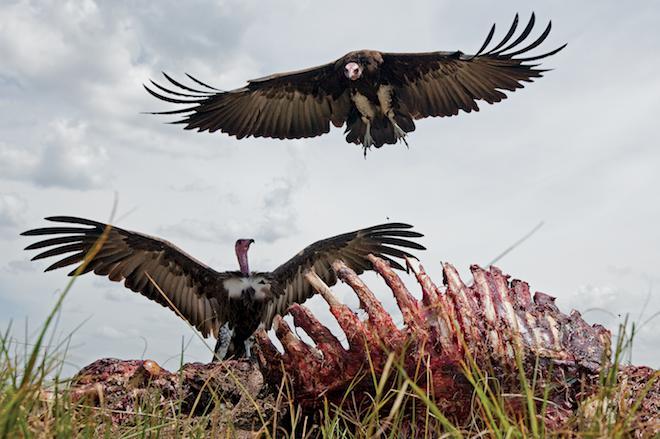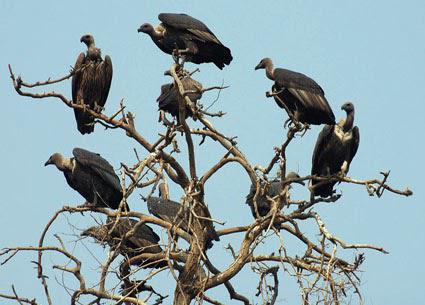The first image is the image on the left, the second image is the image on the right. Analyze the images presented: Is the assertion "A single bird is landing with its wings spread in the image on the right." valid? Answer yes or no. No. The first image is the image on the left, the second image is the image on the right. Evaluate the accuracy of this statement regarding the images: "An image shows a group of vultures perched on something that is elevated.". Is it true? Answer yes or no. Yes. 